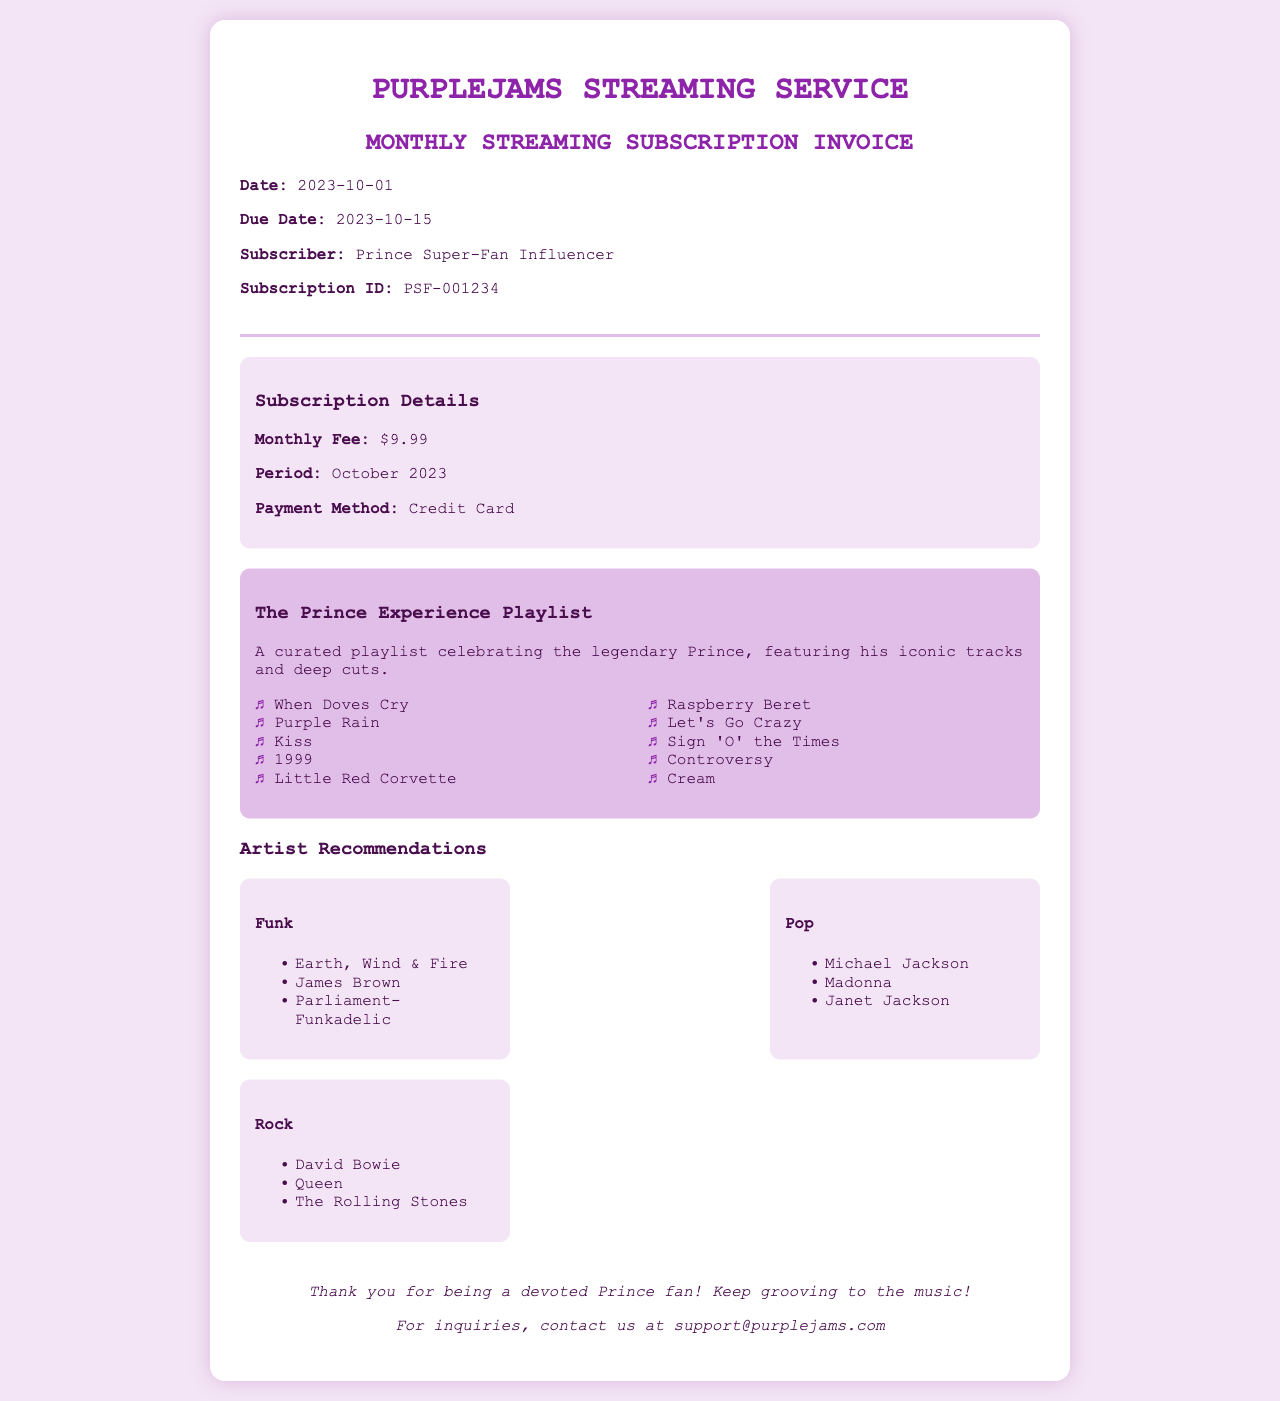What is the title of the invoice? The title is displayed prominently at the top of the document.
Answer: Monthly Streaming Subscription Invoice What is the subscription fee? The subscription fee is listed under the subscription details section.
Answer: $9.99 Who is the subscriber? The subscriber's name is provided near the top of the document.
Answer: Prince Super-Fan Influencer What is the due date for the invoice? The due date is stated clearly in the header section of the invoice.
Answer: 2023-10-15 How many tracks are in "The Prince Experience Playlist"? The number of tracks is given in the playlist section.
Answer: 10 What payment method is used for the subscription? The payment method is outlined in the subscription details.
Answer: Credit Card Name one artist from the funk recommendations. Artists are listed under each genre in separate sections, focusing on recommendations.
Answer: Earth, Wind & Fire What color theme is used for the invoice background? The background color of the document is described in the CSS styling.
Answer: Light purple Is there a contact email for inquiries? Contact information is located in the footer section of the document.
Answer: support@purplejams.com 